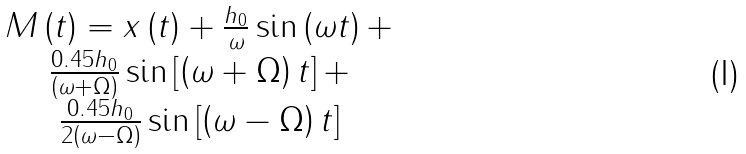Convert formula to latex. <formula><loc_0><loc_0><loc_500><loc_500>\begin{array} { c } M \left ( t \right ) = x \left ( t \right ) + \frac { h _ { 0 } } { \omega } \sin \left ( \omega t \right ) + \\ \frac { 0 . 4 5 h _ { 0 } } { \left ( \omega + \Omega \right ) } \sin \left [ \left ( \omega + \Omega \right ) t \right ] + \\ \frac { 0 . 4 5 h _ { 0 } } { 2 \left ( \omega - \Omega \right ) } \sin \left [ \left ( \omega - \Omega \right ) t \right ] \end{array}</formula> 